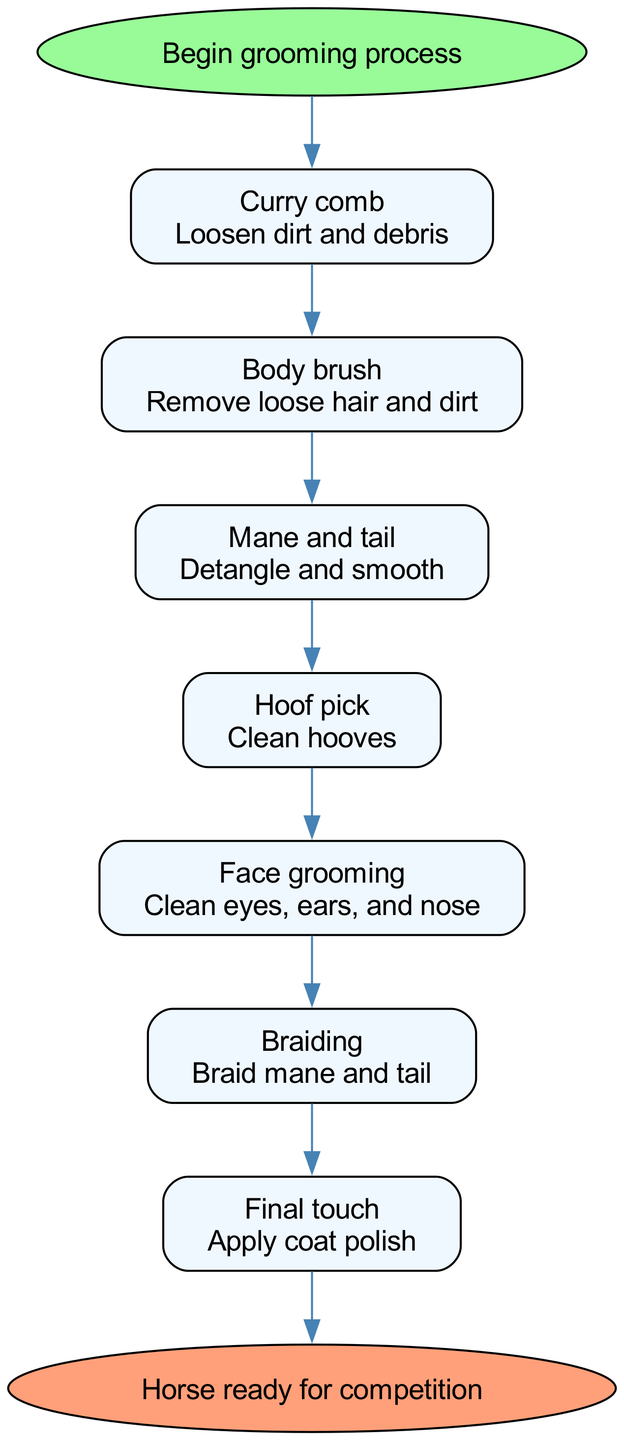What is the first step in the grooming process? The diagram begins with the "Curry comb" step, which is the first node after the start node.
Answer: Curry comb How many steps are involved in the grooming process? By counting each step in the diagram, there are a total of 7 steps listed from "Curry comb" to "Braiding."
Answer: 7 What does the "Face grooming" step involve? The diagram specifies that "Face grooming" means cleaning the eyes, ears, and nose of the horse.
Answer: Clean eyes, ears, and nose Which step comes immediately after "Hoof pick"? The diagram shows that "Face grooming" is the next step that follows "Hoof pick." Looking at the flow, "Face grooming" is connected directly to "Hoof pick."
Answer: Face grooming What is the final action taken before the horse is ready for competition? At the end of the diagram, the last step before reaching "Horse ready for competition" is "Final touch." This indicates that applying coat polish is the last task to complete.
Answer: Apply coat polish What is the purpose of the "Mane and tail" step? The diagram indicates that this step is focused on detangling and smoothing the mane and tail, which is important for presenting the horse well.
Answer: Detangle and smooth What color is used for the end node in the diagram? By observing the diagram, the end node labeled "Horse ready for competition" is filled with the color #FFA07A, indicating its distinct endpoint.
Answer: #FFA07A 